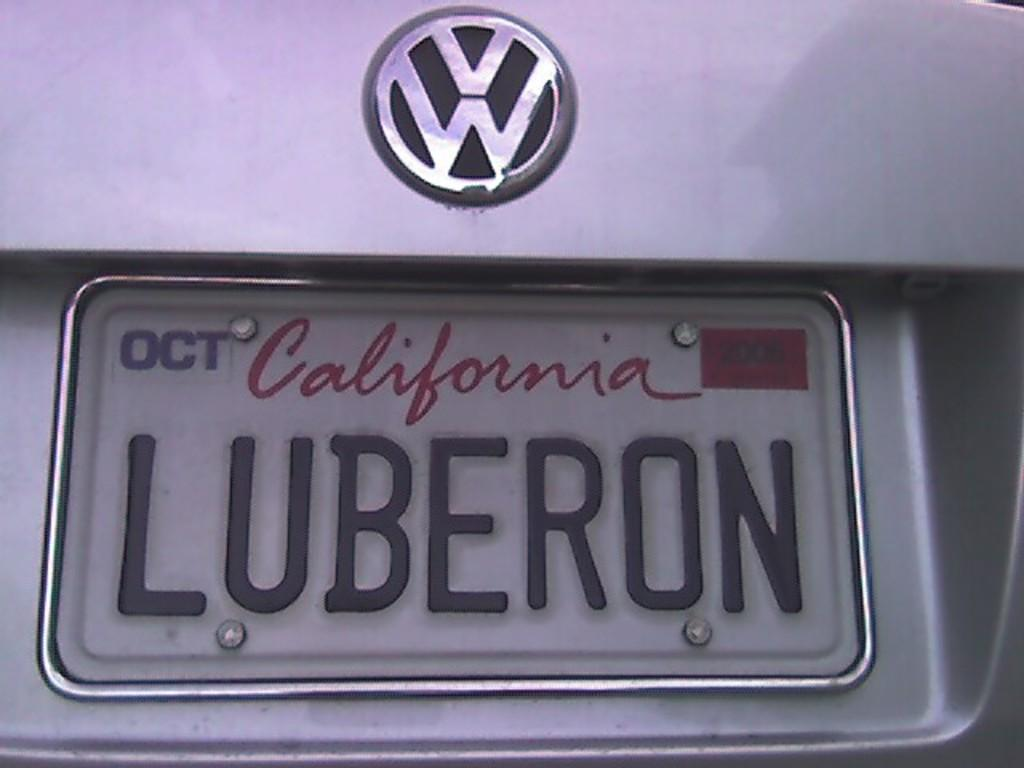Provide a one-sentence caption for the provided image. A Californian licence plate on a VW car. 